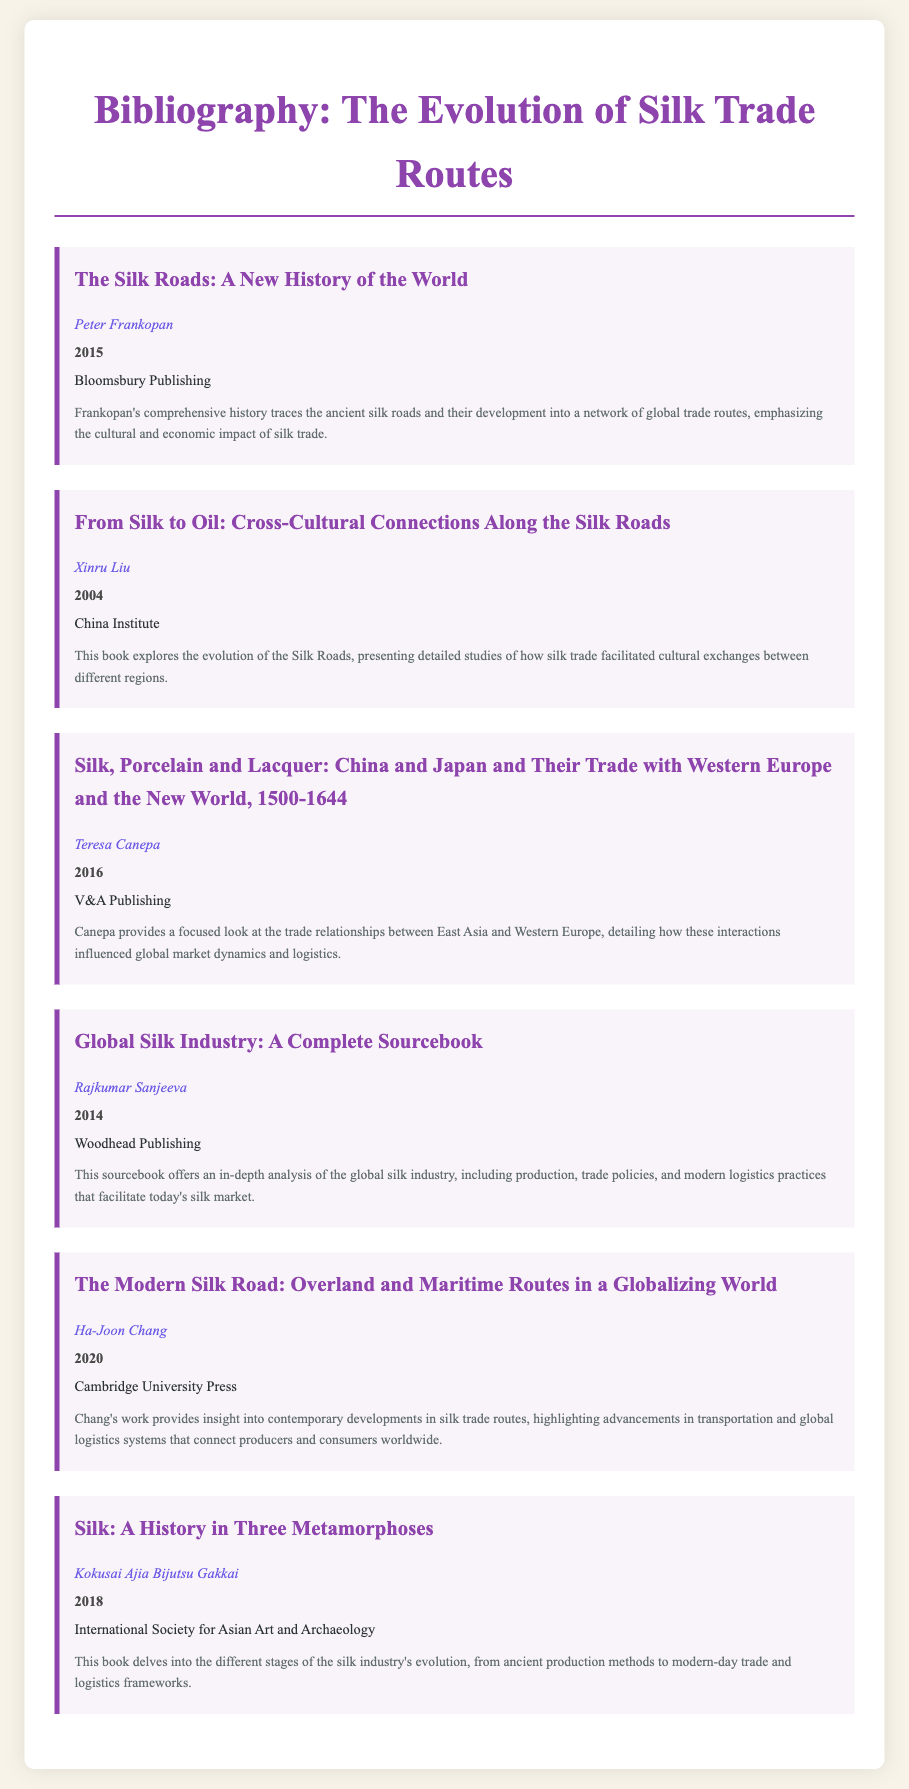What is the title of Peter Frankopan's book? The title is listed at the top of Peter Frankopan's entry under his name and year.
Answer: The Silk Roads: A New History of the World Who published "From Silk to Oil"? The publisher's name is found in the entry for Xinru Liu's book.
Answer: China Institute What year was "Silk, Porcelain and Lacquer" published? The year is provided directly following the author's name in the respective entry.
Answer: 2016 Which author wrote about the global silk industry? The author's name can be identified in the corresponding entry about the silk industry.
Answer: Rajkumar Sanjeeva What is a key theme in Ha-Joon Chang's book? The theme is explained in the description of the book's content focusing on modern developments.
Answer: Contemporary developments in silk trade routes Which book discusses cultural exchanges along the Silk Roads? The description specifically mentions cultural exchanges in Xinru Liu's work.
Answer: From Silk to Oil: Cross-Cultural Connections Along the Silk Roads What is the publisher of "The Modern Silk Road"? The publisher's name is mentioned at the bottom of Ha-Joon Chang's entry.
Answer: Cambridge University Press How many books are listed in this bibliography? The total number of entries can be counted in the document.
Answer: Six 